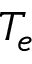<formula> <loc_0><loc_0><loc_500><loc_500>T _ { e }</formula> 